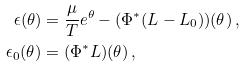<formula> <loc_0><loc_0><loc_500><loc_500>\epsilon ( \theta ) & = \frac { \mu } { T } e ^ { \theta } - ( \Phi ^ { * } ( L - L _ { 0 } ) ) ( \theta ) \, , \\ \epsilon _ { 0 } ( \theta ) & = ( \Phi ^ { * } L ) ( \theta ) \, ,</formula> 